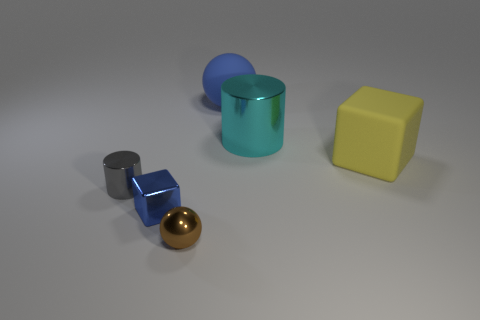What is the shape of the thing that is both in front of the big cylinder and right of the large ball?
Make the answer very short. Cube. There is a metallic cylinder that is on the left side of the tiny brown object; how big is it?
Provide a short and direct response. Small. Does the gray thing have the same size as the brown metallic thing?
Provide a succinct answer. Yes. Is the number of metal things right of the rubber block less than the number of blue matte spheres behind the brown object?
Ensure brevity in your answer.  Yes. What is the size of the shiny thing that is on the right side of the metallic cube and behind the blue block?
Your answer should be compact. Large. Are there any big cubes that are behind the tiny shiny object to the right of the blue object that is in front of the blue rubber object?
Your response must be concise. Yes. Are any metallic cylinders visible?
Your answer should be very brief. Yes. Is the number of big rubber objects in front of the cyan shiny object greater than the number of tiny gray metallic cylinders behind the tiny gray cylinder?
Your answer should be very brief. Yes. What size is the ball that is made of the same material as the big cube?
Make the answer very short. Large. There is a metal cylinder in front of the shiny thing that is behind the small gray thing that is left of the large cyan metal cylinder; what is its size?
Make the answer very short. Small. 